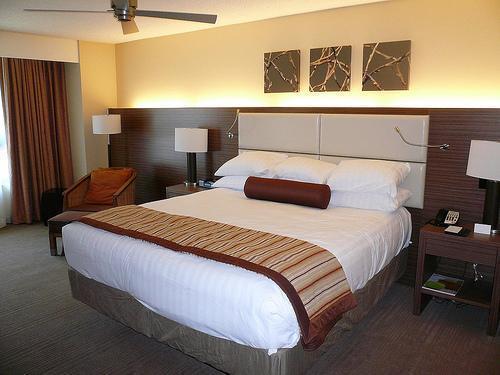How many pillows are on the bed?
Give a very brief answer. 7. How many prints are on the wall?
Give a very brief answer. 3. How many segments are in the headboard?
Give a very brief answer. 4. How many pieces of art are haning on the wall?
Give a very brief answer. 3. How many bowls are on the bed?
Give a very brief answer. 0. 